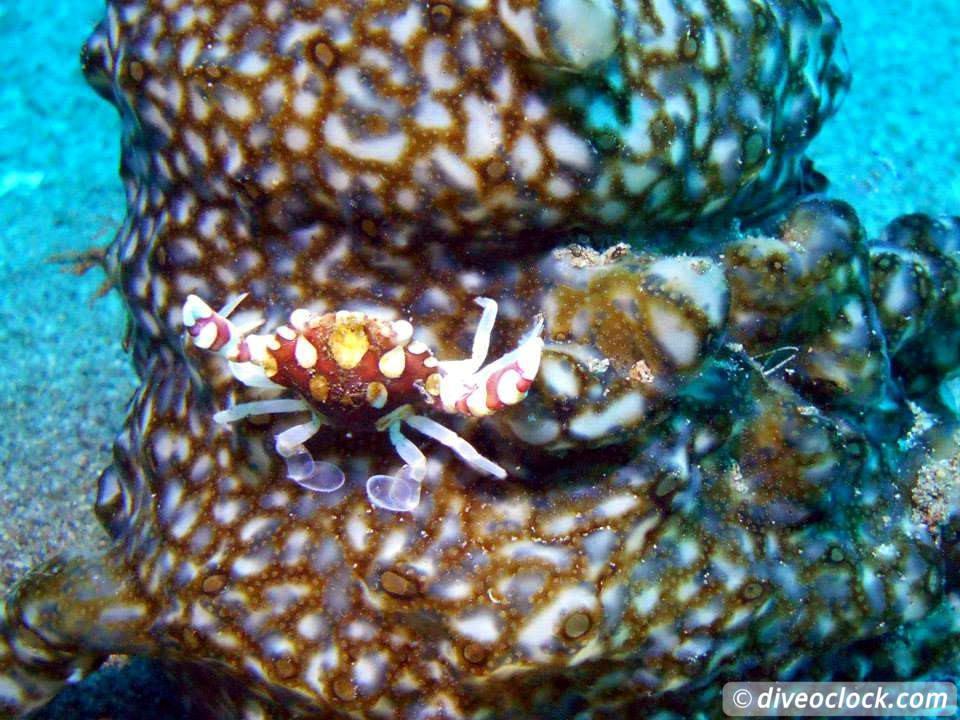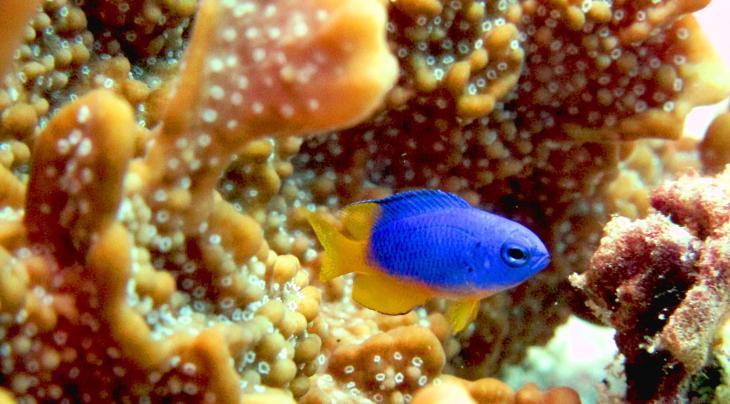The first image is the image on the left, the second image is the image on the right. For the images shown, is this caption "The right image contains some creature with black and white stripes and with two antenna-type horns and something flower-like sprouting from its back." true? Answer yes or no. No. The first image is the image on the left, the second image is the image on the right. Considering the images on both sides, is "A white and black striped fish is swimming in the water in the image on the right." valid? Answer yes or no. No. 